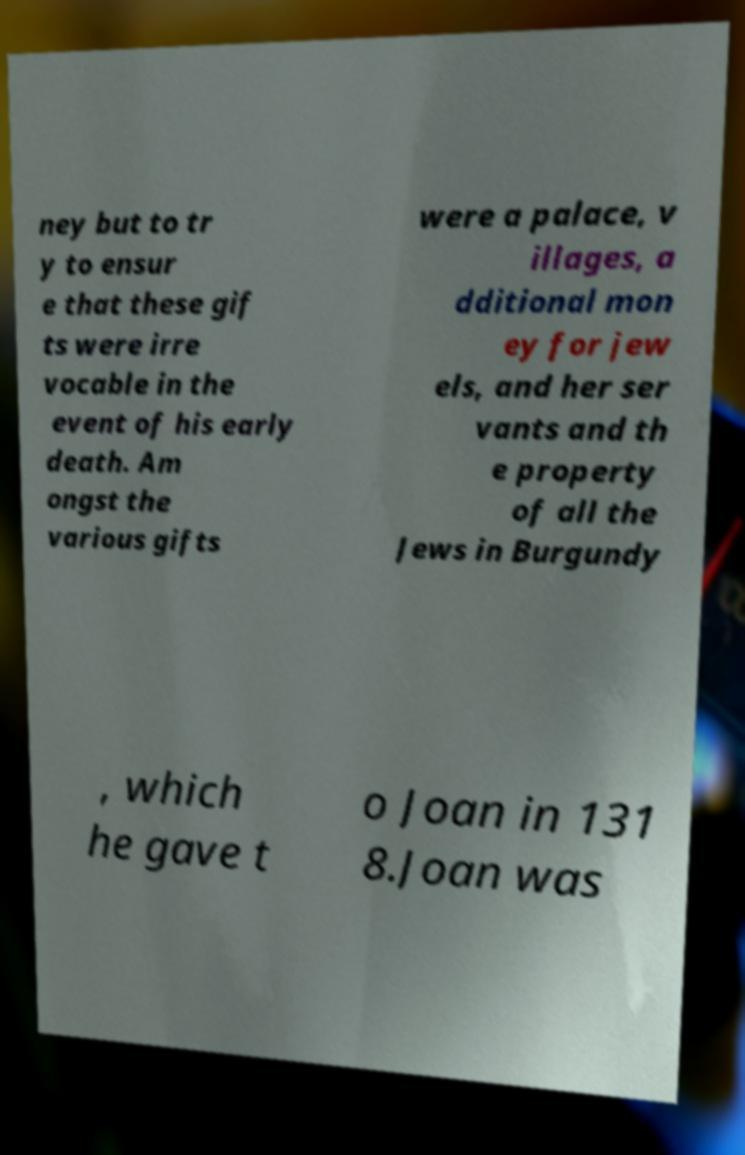For documentation purposes, I need the text within this image transcribed. Could you provide that? ney but to tr y to ensur e that these gif ts were irre vocable in the event of his early death. Am ongst the various gifts were a palace, v illages, a dditional mon ey for jew els, and her ser vants and th e property of all the Jews in Burgundy , which he gave t o Joan in 131 8.Joan was 